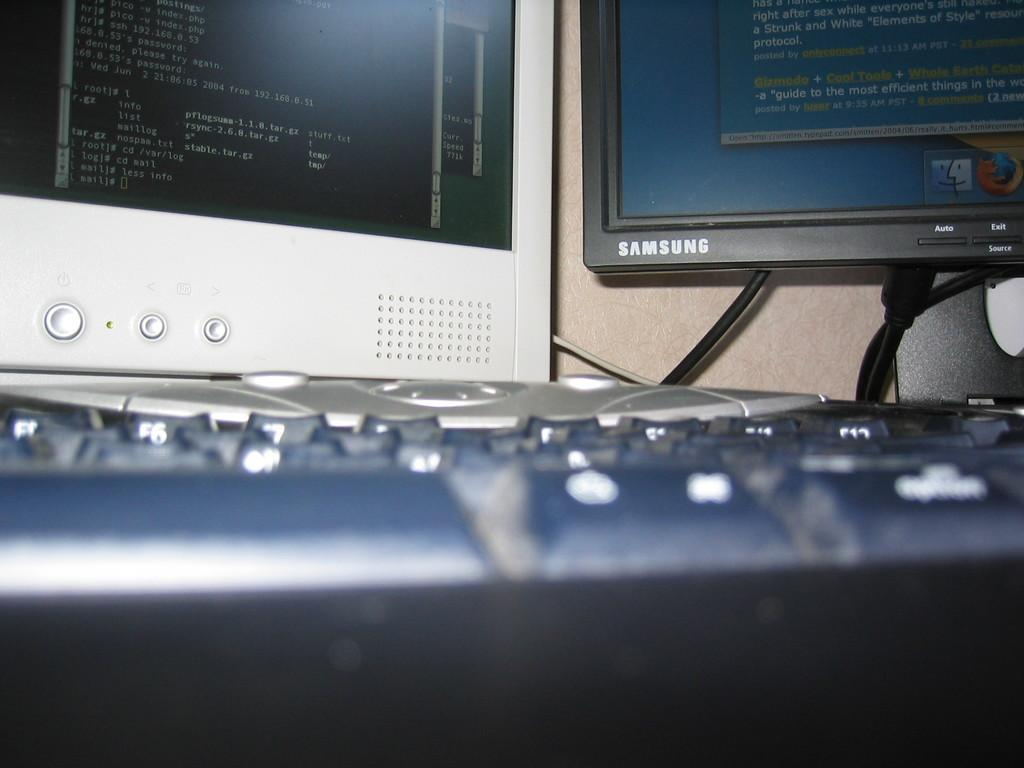<image>
Create a compact narrative representing the image presented. Samsung monitor next to a white monitor with no name. 